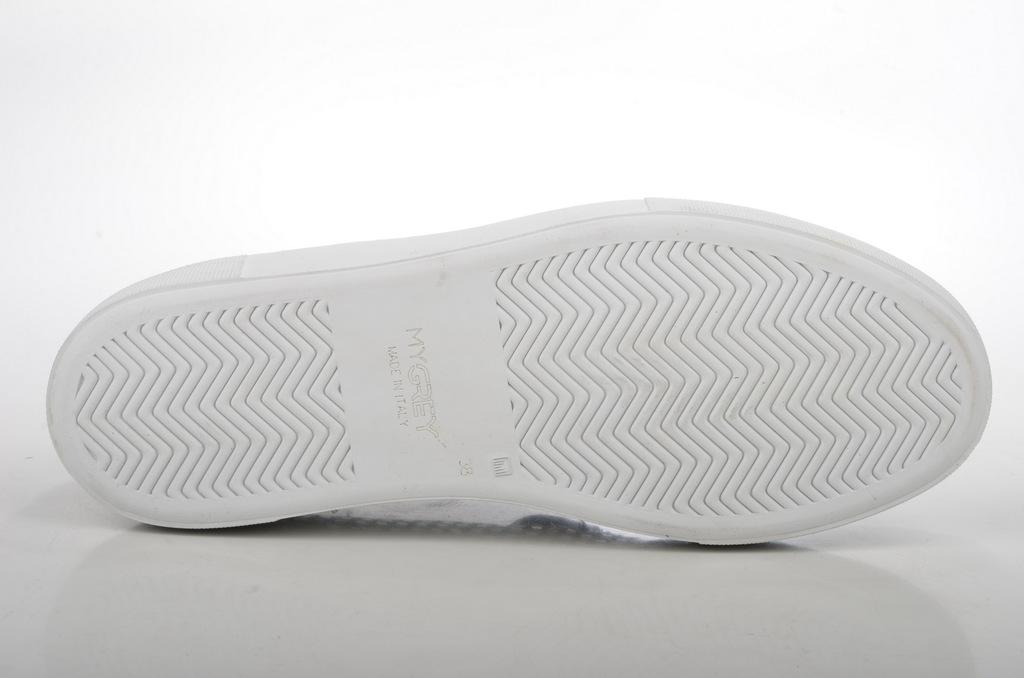What type of object is present in the image? There is footwear in the image. Can you describe the background of the image? The background of the image appears to be white. Is there a lead object visible in the image? There is no lead object present in the image. Can you see a crown on the footwear in the image? There is no crown visible on the footwear in the image. 